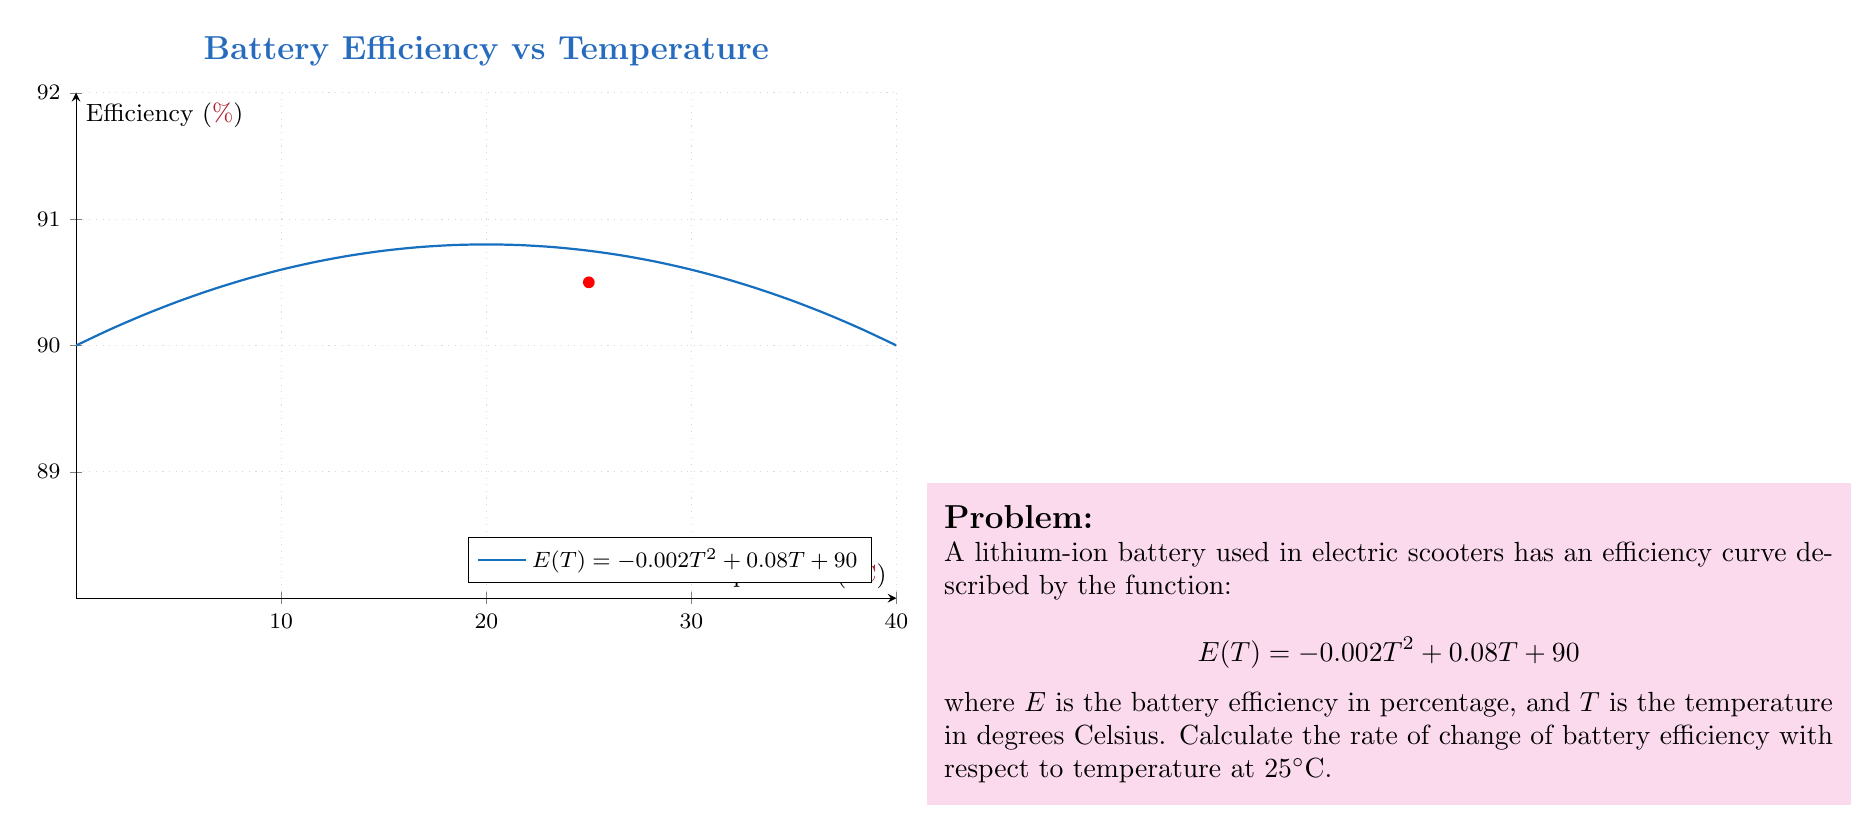Could you help me with this problem? To find the rate of change of battery efficiency with respect to temperature, we need to calculate the derivative of the efficiency function $E(T)$ and evaluate it at $T = 25°C$.

Step 1: Find the derivative of $E(T)$
$$E(T) = -0.002T^2 + 0.08T + 90$$
$$\frac{dE}{dT} = -0.004T + 0.08$$

Step 2: Evaluate the derivative at $T = 25°C$
$$\left.\frac{dE}{dT}\right|_{T=25} = -0.004(25) + 0.08$$
$$= -0.1 + 0.08$$
$$= -0.02$$

The negative value indicates that the efficiency is decreasing at this temperature.

Step 3: Interpret the result
The rate of change of battery efficiency with respect to temperature at 25°C is -0.02% per degree Celsius. This means that for each degree Celsius increase in temperature around 25°C, the battery efficiency decreases by 0.02%.
Answer: $-0.02\%/°C$ 